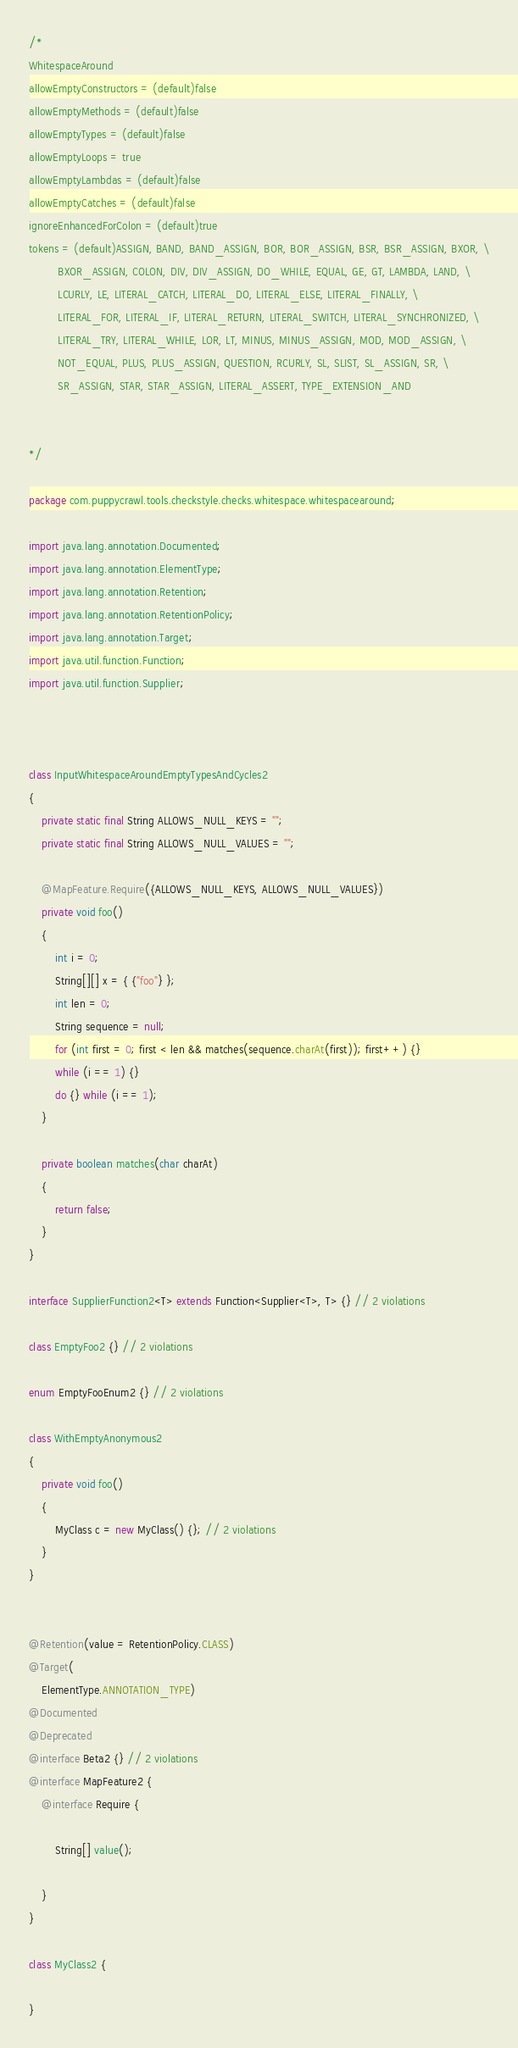Convert code to text. <code><loc_0><loc_0><loc_500><loc_500><_Java_>/*
WhitespaceAround
allowEmptyConstructors = (default)false
allowEmptyMethods = (default)false
allowEmptyTypes = (default)false
allowEmptyLoops = true
allowEmptyLambdas = (default)false
allowEmptyCatches = (default)false
ignoreEnhancedForColon = (default)true
tokens = (default)ASSIGN, BAND, BAND_ASSIGN, BOR, BOR_ASSIGN, BSR, BSR_ASSIGN, BXOR, \
         BXOR_ASSIGN, COLON, DIV, DIV_ASSIGN, DO_WHILE, EQUAL, GE, GT, LAMBDA, LAND, \
         LCURLY, LE, LITERAL_CATCH, LITERAL_DO, LITERAL_ELSE, LITERAL_FINALLY, \
         LITERAL_FOR, LITERAL_IF, LITERAL_RETURN, LITERAL_SWITCH, LITERAL_SYNCHRONIZED, \
         LITERAL_TRY, LITERAL_WHILE, LOR, LT, MINUS, MINUS_ASSIGN, MOD, MOD_ASSIGN, \
         NOT_EQUAL, PLUS, PLUS_ASSIGN, QUESTION, RCURLY, SL, SLIST, SL_ASSIGN, SR, \
         SR_ASSIGN, STAR, STAR_ASSIGN, LITERAL_ASSERT, TYPE_EXTENSION_AND


*/

package com.puppycrawl.tools.checkstyle.checks.whitespace.whitespacearound;

import java.lang.annotation.Documented;
import java.lang.annotation.ElementType;
import java.lang.annotation.Retention;
import java.lang.annotation.RetentionPolicy;
import java.lang.annotation.Target;
import java.util.function.Function;
import java.util.function.Supplier;



class InputWhitespaceAroundEmptyTypesAndCycles2
{
    private static final String ALLOWS_NULL_KEYS = "";
    private static final String ALLOWS_NULL_VALUES = "";

    @MapFeature.Require({ALLOWS_NULL_KEYS, ALLOWS_NULL_VALUES})
    private void foo()
    {
        int i = 0;
        String[][] x = { {"foo"} };
        int len = 0;
        String sequence = null;
        for (int first = 0; first < len && matches(sequence.charAt(first)); first++) {}
        while (i == 1) {}
        do {} while (i == 1);
    }

    private boolean matches(char charAt)
    {
        return false;
    }
}

interface SupplierFunction2<T> extends Function<Supplier<T>, T> {} // 2 violations

class EmptyFoo2 {} // 2 violations

enum EmptyFooEnum2 {} // 2 violations

class WithEmptyAnonymous2
{
    private void foo()
    {
        MyClass c = new MyClass() {}; // 2 violations
    }
}


@Retention(value = RetentionPolicy.CLASS)
@Target(
    ElementType.ANNOTATION_TYPE)
@Documented
@Deprecated
@interface Beta2 {} // 2 violations
@interface MapFeature2 {
    @interface Require {

        String[] value();

    }
}

class MyClass2 {

}
</code> 